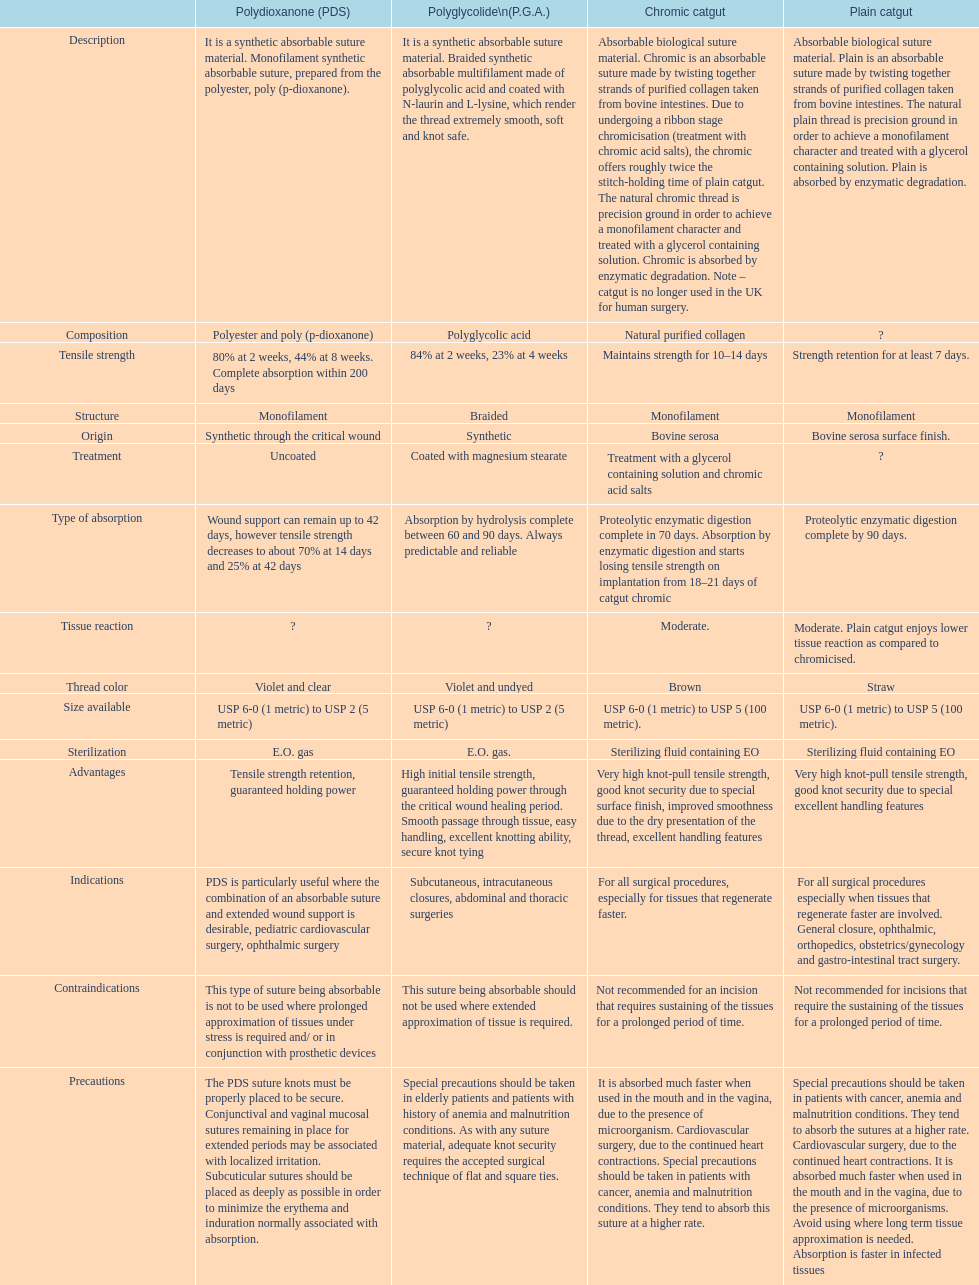What categories are listed in the suture materials comparison chart? Description, Composition, Tensile strength, Structure, Origin, Treatment, Type of absorption, Tissue reaction, Thread color, Size available, Sterilization, Advantages, Indications, Contraindications, Precautions. Of the testile strength, which is the lowest? Strength retention for at least 7 days. 